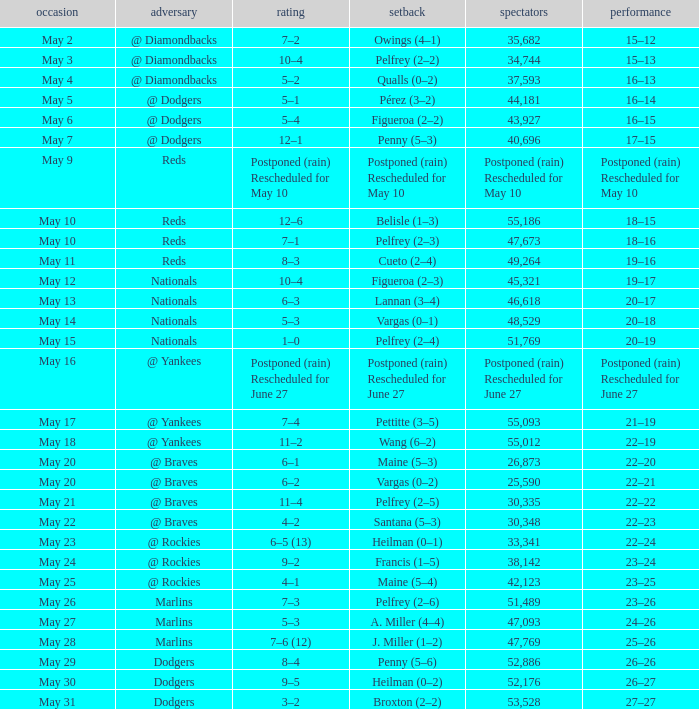When did the 19-16 incident transpire? May 11. 